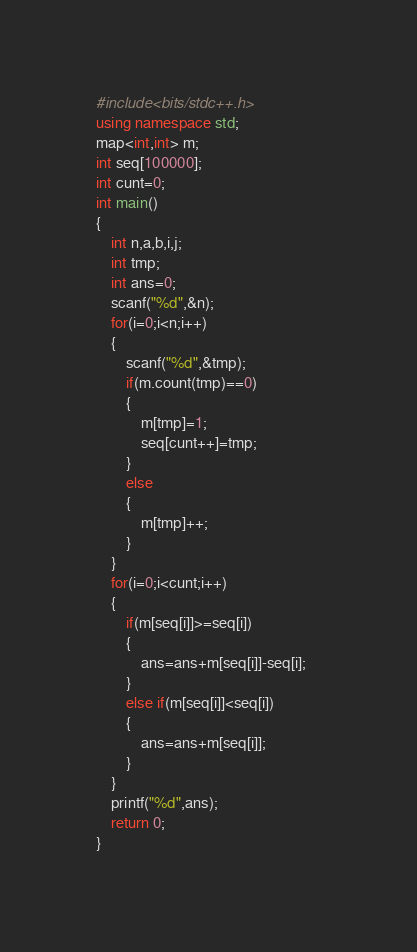<code> <loc_0><loc_0><loc_500><loc_500><_C++_>#include<bits/stdc++.h>
using namespace std;
map<int,int> m;
int seq[100000];
int cunt=0;
int main()
{
	int n,a,b,i,j;
	int tmp;
	int ans=0;
	scanf("%d",&n);
	for(i=0;i<n;i++)
	{
		scanf("%d",&tmp);
		if(m.count(tmp)==0)
		{
			m[tmp]=1;
			seq[cunt++]=tmp;
		}			
		else
		{
			m[tmp]++;
		}
	}
	for(i=0;i<cunt;i++)
	{
		if(m[seq[i]]>=seq[i])
		{
			ans=ans+m[seq[i]]-seq[i];	
		}
		else if(m[seq[i]]<seq[i])
		{
			ans=ans+m[seq[i]];
		}
	}
	printf("%d",ans);
	return 0;
}</code> 